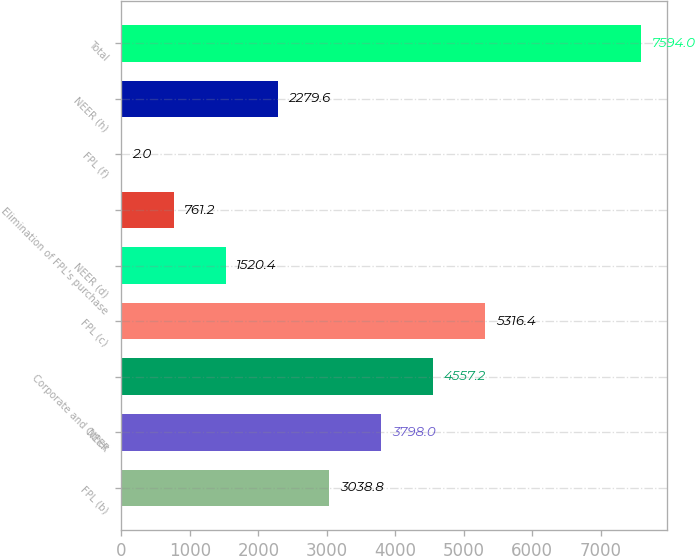<chart> <loc_0><loc_0><loc_500><loc_500><bar_chart><fcel>FPL (b)<fcel>NEER<fcel>Corporate and Other<fcel>FPL (c)<fcel>NEER (d)<fcel>Elimination of FPL's purchase<fcel>FPL (f)<fcel>NEER (h)<fcel>Total<nl><fcel>3038.8<fcel>3798<fcel>4557.2<fcel>5316.4<fcel>1520.4<fcel>761.2<fcel>2<fcel>2279.6<fcel>7594<nl></chart> 